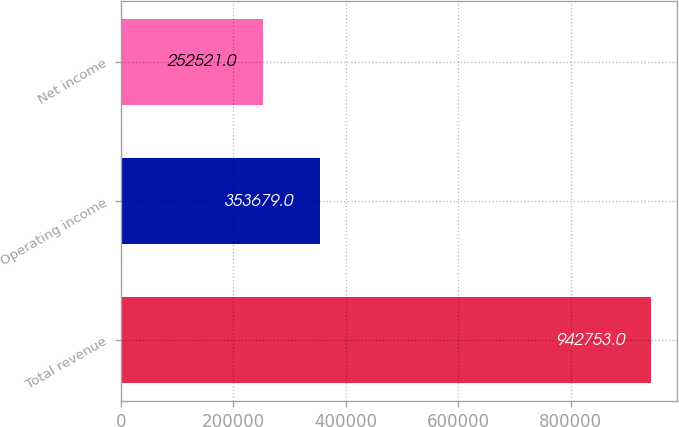Convert chart to OTSL. <chart><loc_0><loc_0><loc_500><loc_500><bar_chart><fcel>Total revenue<fcel>Operating income<fcel>Net income<nl><fcel>942753<fcel>353679<fcel>252521<nl></chart> 